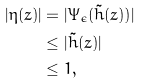Convert formula to latex. <formula><loc_0><loc_0><loc_500><loc_500>| \eta ( z ) | & = | \Psi _ { \epsilon } ( \tilde { h } ( z ) ) | \\ & \leq | \tilde { h } ( z ) | \\ & \leq 1 ,</formula> 